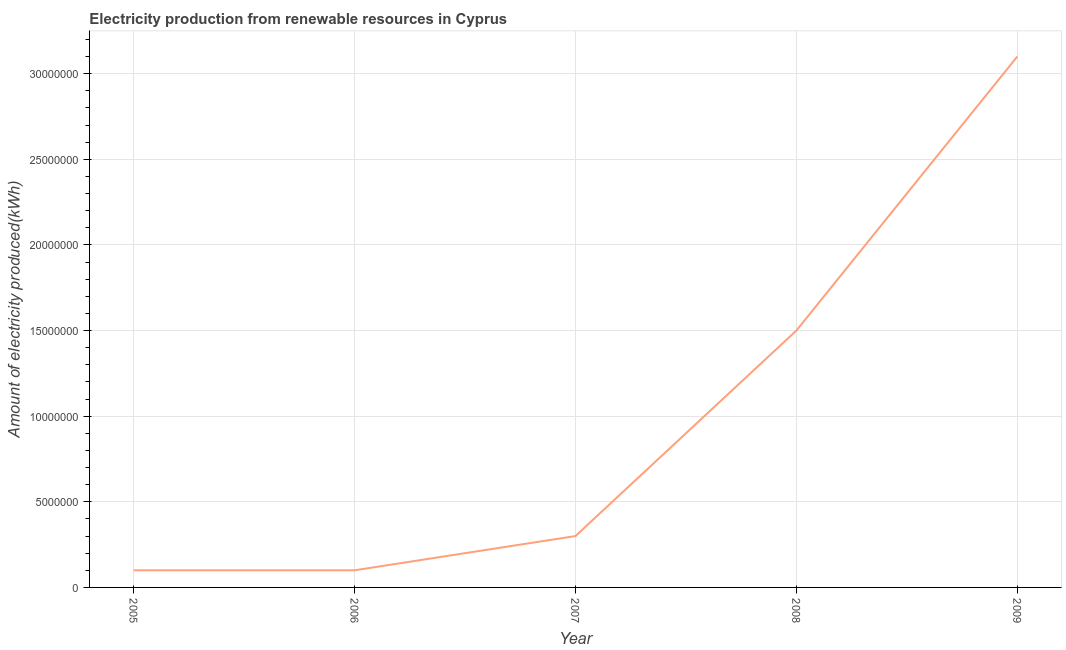What is the amount of electricity produced in 2008?
Provide a succinct answer. 1.50e+07. Across all years, what is the maximum amount of electricity produced?
Provide a succinct answer. 3.10e+07. Across all years, what is the minimum amount of electricity produced?
Provide a short and direct response. 1.00e+06. In which year was the amount of electricity produced maximum?
Provide a short and direct response. 2009. In which year was the amount of electricity produced minimum?
Your answer should be compact. 2005. What is the sum of the amount of electricity produced?
Offer a terse response. 5.10e+07. What is the difference between the amount of electricity produced in 2008 and 2009?
Offer a very short reply. -1.60e+07. What is the average amount of electricity produced per year?
Offer a terse response. 1.02e+07. What is the median amount of electricity produced?
Give a very brief answer. 3.00e+06. Do a majority of the years between 2009 and 2006 (inclusive) have amount of electricity produced greater than 25000000 kWh?
Make the answer very short. Yes. What is the ratio of the amount of electricity produced in 2005 to that in 2006?
Your answer should be compact. 1. Is the amount of electricity produced in 2006 less than that in 2009?
Make the answer very short. Yes. Is the difference between the amount of electricity produced in 2005 and 2009 greater than the difference between any two years?
Offer a very short reply. Yes. What is the difference between the highest and the second highest amount of electricity produced?
Give a very brief answer. 1.60e+07. What is the difference between the highest and the lowest amount of electricity produced?
Keep it short and to the point. 3.00e+07. How many lines are there?
Make the answer very short. 1. How many years are there in the graph?
Offer a terse response. 5. Does the graph contain any zero values?
Make the answer very short. No. What is the title of the graph?
Provide a short and direct response. Electricity production from renewable resources in Cyprus. What is the label or title of the Y-axis?
Your answer should be compact. Amount of electricity produced(kWh). What is the Amount of electricity produced(kWh) in 2005?
Provide a succinct answer. 1.00e+06. What is the Amount of electricity produced(kWh) of 2007?
Provide a short and direct response. 3.00e+06. What is the Amount of electricity produced(kWh) of 2008?
Provide a short and direct response. 1.50e+07. What is the Amount of electricity produced(kWh) in 2009?
Provide a short and direct response. 3.10e+07. What is the difference between the Amount of electricity produced(kWh) in 2005 and 2007?
Your answer should be compact. -2.00e+06. What is the difference between the Amount of electricity produced(kWh) in 2005 and 2008?
Provide a succinct answer. -1.40e+07. What is the difference between the Amount of electricity produced(kWh) in 2005 and 2009?
Your response must be concise. -3.00e+07. What is the difference between the Amount of electricity produced(kWh) in 2006 and 2007?
Your answer should be very brief. -2.00e+06. What is the difference between the Amount of electricity produced(kWh) in 2006 and 2008?
Offer a terse response. -1.40e+07. What is the difference between the Amount of electricity produced(kWh) in 2006 and 2009?
Keep it short and to the point. -3.00e+07. What is the difference between the Amount of electricity produced(kWh) in 2007 and 2008?
Your response must be concise. -1.20e+07. What is the difference between the Amount of electricity produced(kWh) in 2007 and 2009?
Provide a short and direct response. -2.80e+07. What is the difference between the Amount of electricity produced(kWh) in 2008 and 2009?
Give a very brief answer. -1.60e+07. What is the ratio of the Amount of electricity produced(kWh) in 2005 to that in 2006?
Make the answer very short. 1. What is the ratio of the Amount of electricity produced(kWh) in 2005 to that in 2007?
Keep it short and to the point. 0.33. What is the ratio of the Amount of electricity produced(kWh) in 2005 to that in 2008?
Provide a short and direct response. 0.07. What is the ratio of the Amount of electricity produced(kWh) in 2005 to that in 2009?
Provide a short and direct response. 0.03. What is the ratio of the Amount of electricity produced(kWh) in 2006 to that in 2007?
Ensure brevity in your answer.  0.33. What is the ratio of the Amount of electricity produced(kWh) in 2006 to that in 2008?
Provide a short and direct response. 0.07. What is the ratio of the Amount of electricity produced(kWh) in 2006 to that in 2009?
Provide a succinct answer. 0.03. What is the ratio of the Amount of electricity produced(kWh) in 2007 to that in 2008?
Your answer should be very brief. 0.2. What is the ratio of the Amount of electricity produced(kWh) in 2007 to that in 2009?
Provide a succinct answer. 0.1. What is the ratio of the Amount of electricity produced(kWh) in 2008 to that in 2009?
Provide a succinct answer. 0.48. 